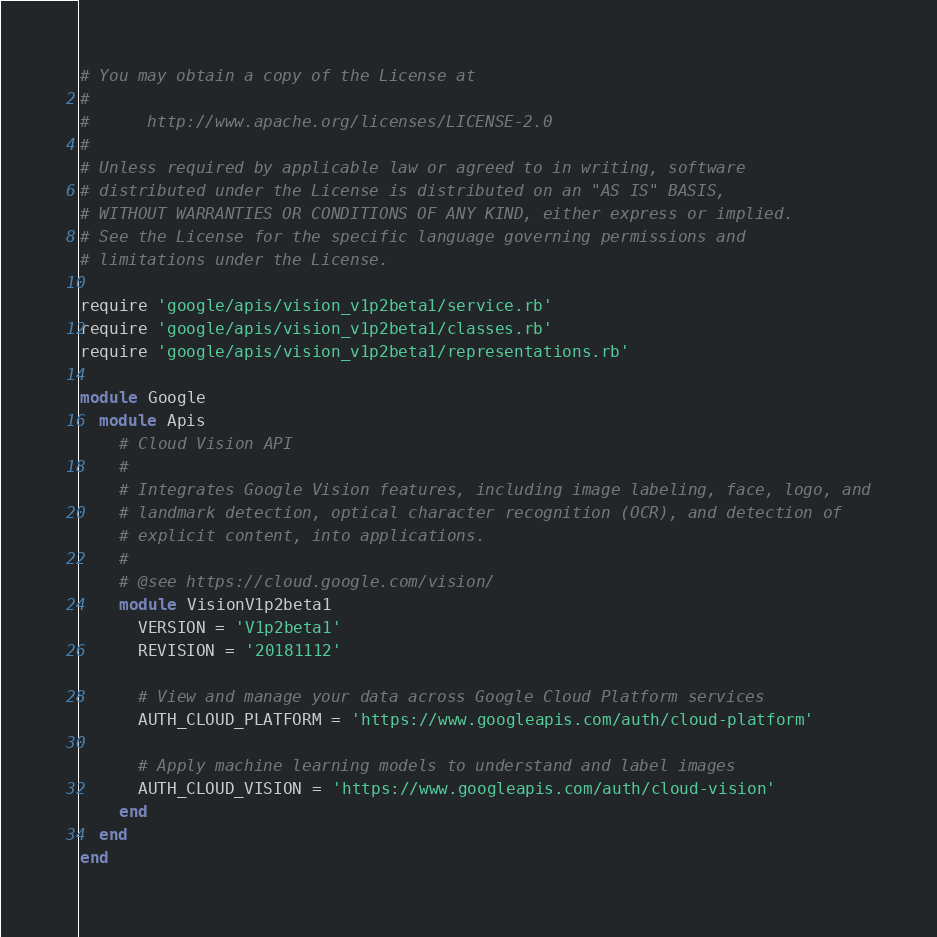<code> <loc_0><loc_0><loc_500><loc_500><_Ruby_># You may obtain a copy of the License at
#
#      http://www.apache.org/licenses/LICENSE-2.0
#
# Unless required by applicable law or agreed to in writing, software
# distributed under the License is distributed on an "AS IS" BASIS,
# WITHOUT WARRANTIES OR CONDITIONS OF ANY KIND, either express or implied.
# See the License for the specific language governing permissions and
# limitations under the License.

require 'google/apis/vision_v1p2beta1/service.rb'
require 'google/apis/vision_v1p2beta1/classes.rb'
require 'google/apis/vision_v1p2beta1/representations.rb'

module Google
  module Apis
    # Cloud Vision API
    #
    # Integrates Google Vision features, including image labeling, face, logo, and
    # landmark detection, optical character recognition (OCR), and detection of
    # explicit content, into applications.
    #
    # @see https://cloud.google.com/vision/
    module VisionV1p2beta1
      VERSION = 'V1p2beta1'
      REVISION = '20181112'

      # View and manage your data across Google Cloud Platform services
      AUTH_CLOUD_PLATFORM = 'https://www.googleapis.com/auth/cloud-platform'

      # Apply machine learning models to understand and label images
      AUTH_CLOUD_VISION = 'https://www.googleapis.com/auth/cloud-vision'
    end
  end
end
</code> 